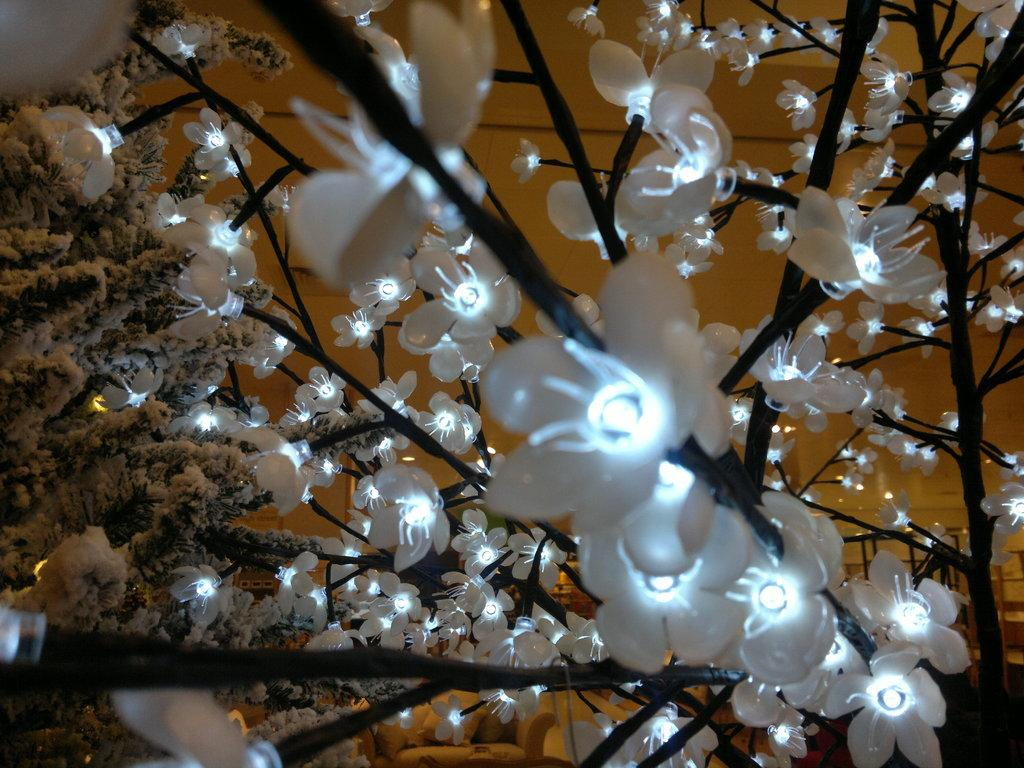What is the main object in the image? There is a tree in the image. What is added to the tree to enhance its appearance? There are flower lights on the tree. How many beggars can be seen near the tree in the image? There are no beggars present in the image; it only features a tree with flower lights. What type of zinc is used to create the flower lights on the tree? There is no mention of zinc being used in the image; the flower lights are not described in terms of their materials. 